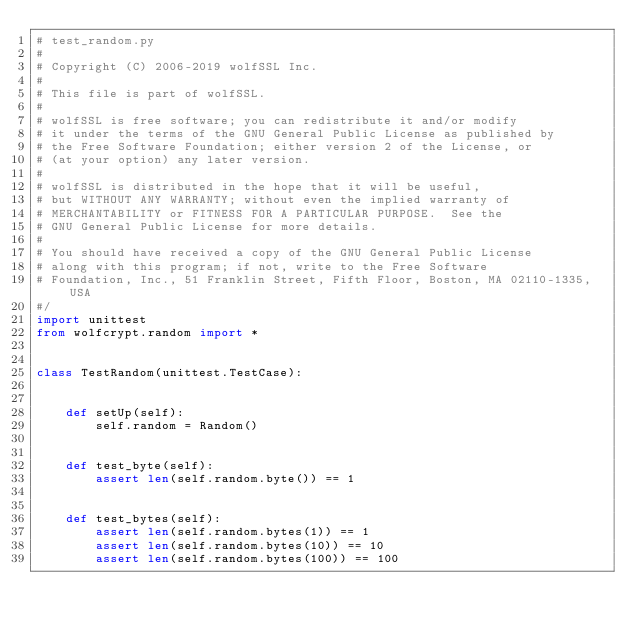Convert code to text. <code><loc_0><loc_0><loc_500><loc_500><_Python_># test_random.py
#
# Copyright (C) 2006-2019 wolfSSL Inc.
#
# This file is part of wolfSSL.
#
# wolfSSL is free software; you can redistribute it and/or modify
# it under the terms of the GNU General Public License as published by
# the Free Software Foundation; either version 2 of the License, or
# (at your option) any later version.
#
# wolfSSL is distributed in the hope that it will be useful,
# but WITHOUT ANY WARRANTY; without even the implied warranty of
# MERCHANTABILITY or FITNESS FOR A PARTICULAR PURPOSE.  See the
# GNU General Public License for more details.
#
# You should have received a copy of the GNU General Public License
# along with this program; if not, write to the Free Software
# Foundation, Inc., 51 Franklin Street, Fifth Floor, Boston, MA 02110-1335, USA
#/
import unittest
from wolfcrypt.random import *


class TestRandom(unittest.TestCase):


    def setUp(self):
        self.random = Random()


    def test_byte(self):
        assert len(self.random.byte()) == 1


    def test_bytes(self):
        assert len(self.random.bytes(1)) == 1
        assert len(self.random.bytes(10)) == 10
        assert len(self.random.bytes(100)) == 100
</code> 